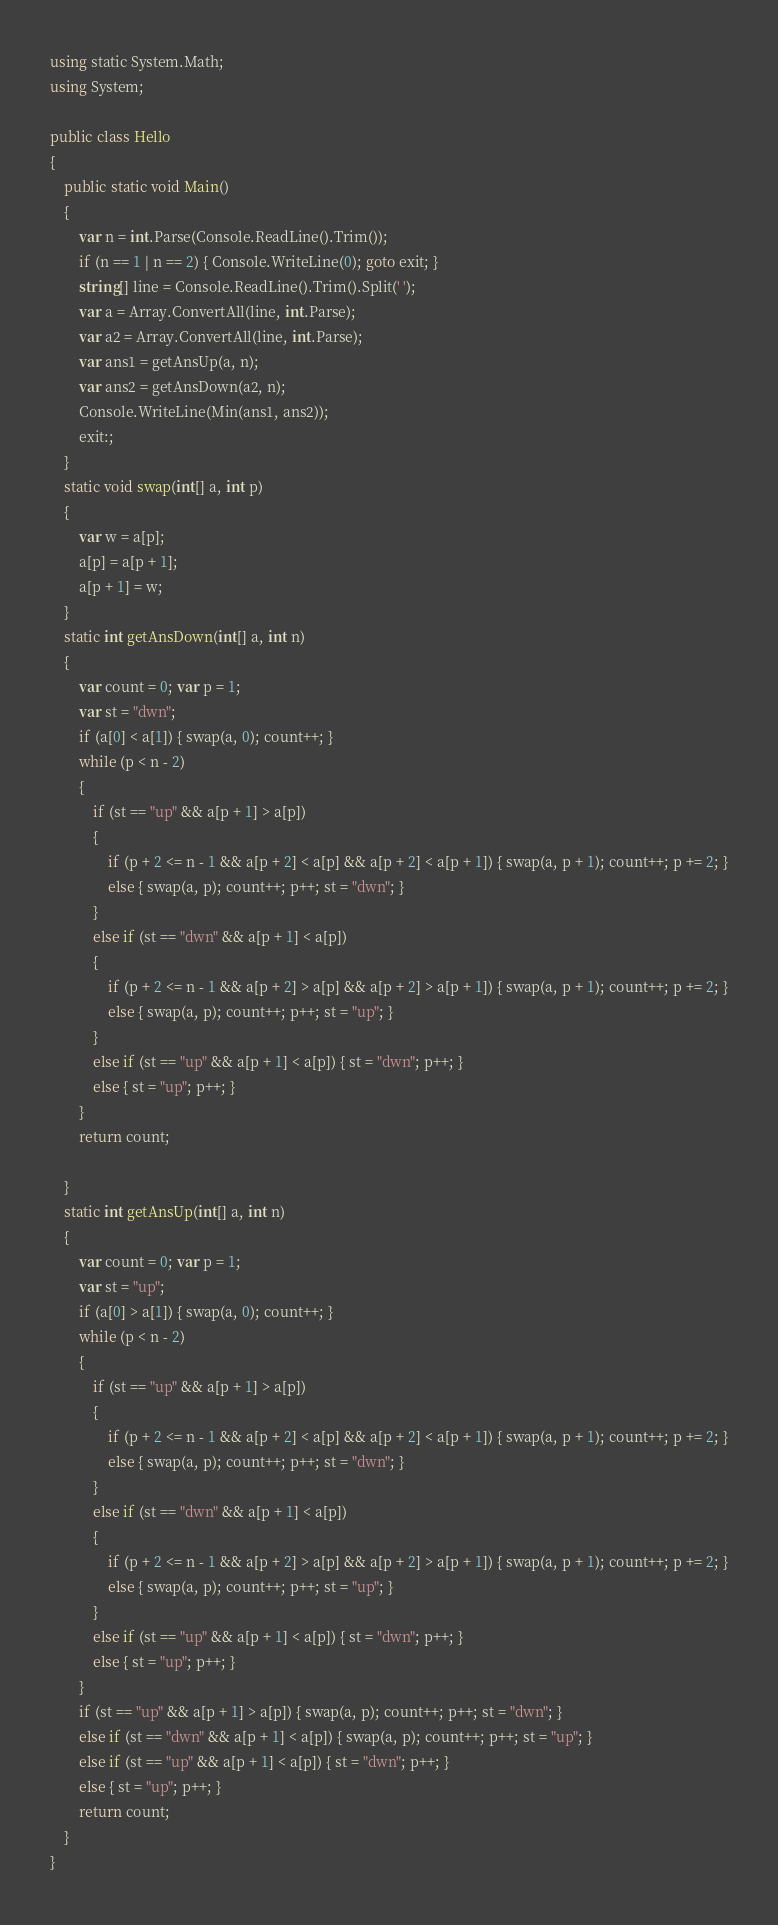Convert code to text. <code><loc_0><loc_0><loc_500><loc_500><_C#_>using static System.Math;
using System;

public class Hello
{
    public static void Main()
    {
        var n = int.Parse(Console.ReadLine().Trim());
        if (n == 1 | n == 2) { Console.WriteLine(0); goto exit; }
        string[] line = Console.ReadLine().Trim().Split(' ');
        var a = Array.ConvertAll(line, int.Parse);
        var a2 = Array.ConvertAll(line, int.Parse);
        var ans1 = getAnsUp(a, n);
        var ans2 = getAnsDown(a2, n);
        Console.WriteLine(Min(ans1, ans2));
        exit:;
    }
    static void swap(int[] a, int p)
    {
        var w = a[p];
        a[p] = a[p + 1];
        a[p + 1] = w;
    }
    static int getAnsDown(int[] a, int n)
    {
        var count = 0; var p = 1;
        var st = "dwn";
        if (a[0] < a[1]) { swap(a, 0); count++; }
        while (p < n - 2)
        {
            if (st == "up" && a[p + 1] > a[p])
            {
                if (p + 2 <= n - 1 && a[p + 2] < a[p] && a[p + 2] < a[p + 1]) { swap(a, p + 1); count++; p += 2; }
                else { swap(a, p); count++; p++; st = "dwn"; }
            }
            else if (st == "dwn" && a[p + 1] < a[p])
            {
                if (p + 2 <= n - 1 && a[p + 2] > a[p] && a[p + 2] > a[p + 1]) { swap(a, p + 1); count++; p += 2; }
                else { swap(a, p); count++; p++; st = "up"; }
            }
            else if (st == "up" && a[p + 1] < a[p]) { st = "dwn"; p++; }
            else { st = "up"; p++; }
        }
        return count;

    }
    static int getAnsUp(int[] a, int n)
    {
        var count = 0; var p = 1;
        var st = "up";
        if (a[0] > a[1]) { swap(a, 0); count++; }
        while (p < n - 2)
        {
            if (st == "up" && a[p + 1] > a[p])
            {
                if (p + 2 <= n - 1 && a[p + 2] < a[p] && a[p + 2] < a[p + 1]) { swap(a, p + 1); count++; p += 2; }
                else { swap(a, p); count++; p++; st = "dwn"; }
            }
            else if (st == "dwn" && a[p + 1] < a[p])
            {
                if (p + 2 <= n - 1 && a[p + 2] > a[p] && a[p + 2] > a[p + 1]) { swap(a, p + 1); count++; p += 2; }
                else { swap(a, p); count++; p++; st = "up"; }
            }
            else if (st == "up" && a[p + 1] < a[p]) { st = "dwn"; p++; }
            else { st = "up"; p++; }
        }
        if (st == "up" && a[p + 1] > a[p]) { swap(a, p); count++; p++; st = "dwn"; }
        else if (st == "dwn" && a[p + 1] < a[p]) { swap(a, p); count++; p++; st = "up"; }
        else if (st == "up" && a[p + 1] < a[p]) { st = "dwn"; p++; }
        else { st = "up"; p++; }
        return count;
    }
}

</code> 